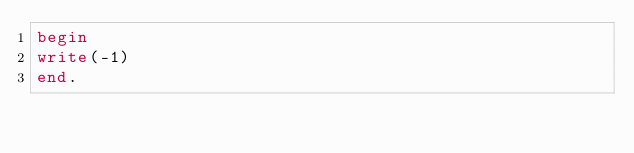<code> <loc_0><loc_0><loc_500><loc_500><_Pascal_>begin
write(-1)
end.</code> 